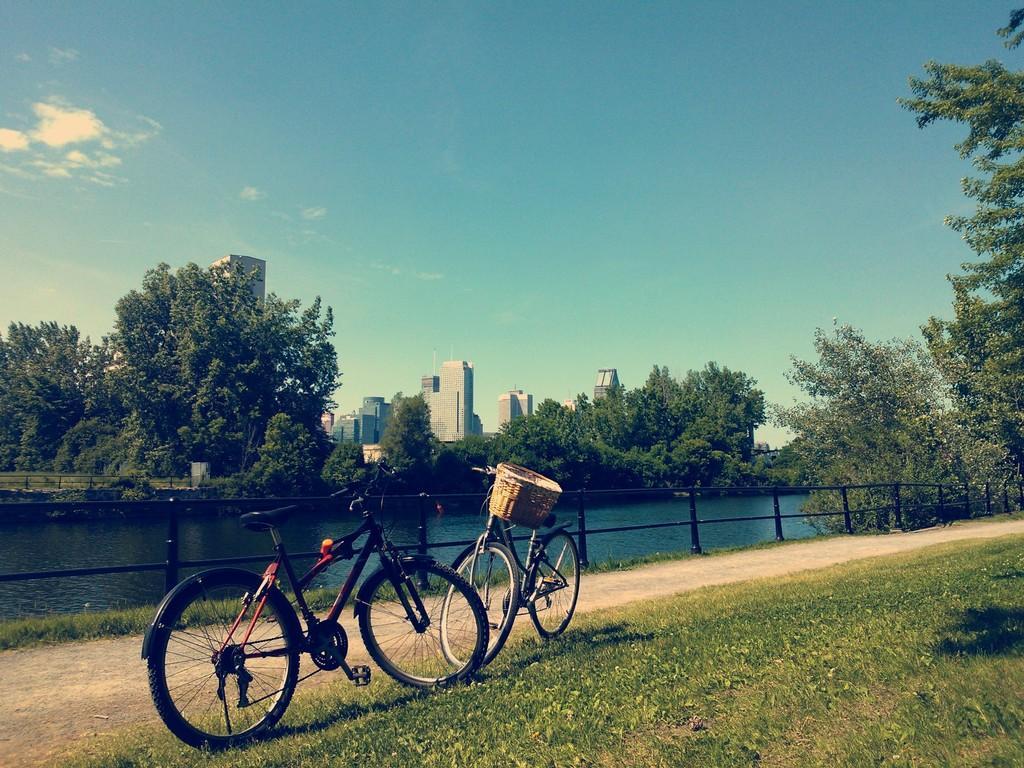Describe this image in one or two sentences. In this image I can see two bicycles. I can see a path. There is some grass on the ground. I can see a railing and the water surface. There are few trees and buildings. At the top I can see clouds in the sky. 